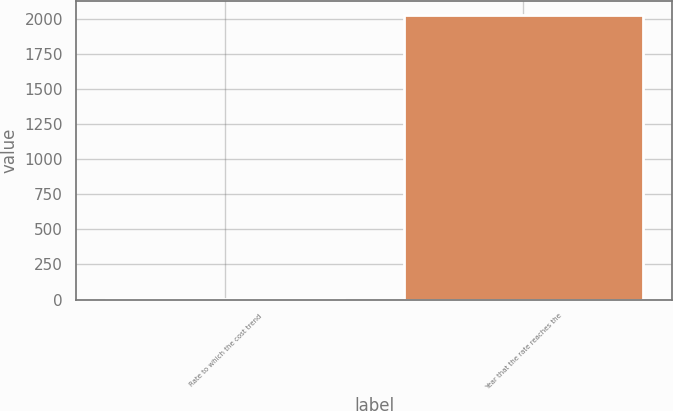Convert chart. <chart><loc_0><loc_0><loc_500><loc_500><bar_chart><fcel>Rate to which the cost trend<fcel>Year that the rate reaches the<nl><fcel>5<fcel>2025<nl></chart> 